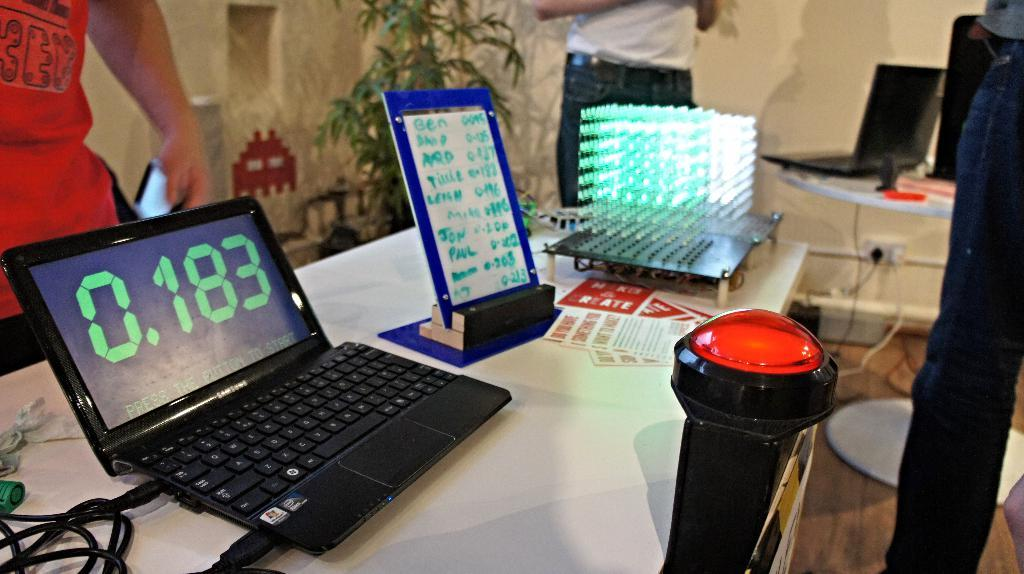What objects are on the table in the image? There are papers, a laptop, cables, a board, and a device on the table. What type of electronic device is on the table? The device on the table is not specified, but it is likely a computer or tablet. What are the persons in the image doing? The persons in the image are standing. Is there any greenery visible in the image? Yes, there is a plant far away in the image. What is the opinion of the sail on the range in the image? There is no sail or range present in the image, so it is not possible to determine any opinions about them. 